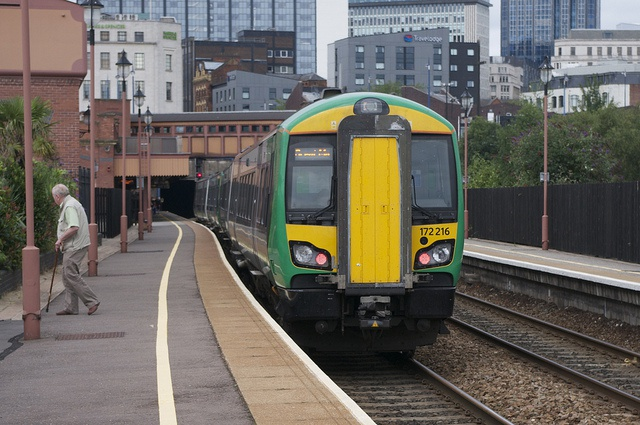Describe the objects in this image and their specific colors. I can see train in gray, black, gold, and teal tones, people in gray, darkgray, and lightgray tones, and traffic light in gray, black, and maroon tones in this image. 